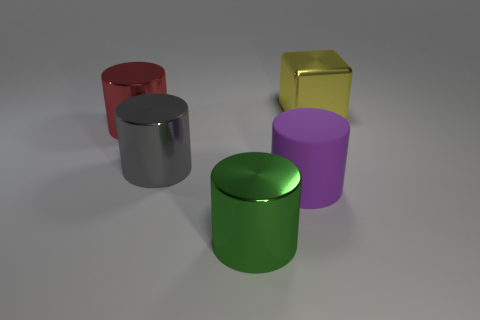Subtract all large purple rubber cylinders. How many cylinders are left? 3 Add 5 large gray things. How many objects exist? 10 Subtract all gray cylinders. How many cylinders are left? 3 Subtract all purple cylinders. Subtract all blue blocks. How many cylinders are left? 3 Subtract all cubes. How many objects are left? 4 Add 1 cyan shiny cylinders. How many cyan shiny cylinders exist? 1 Subtract 1 yellow blocks. How many objects are left? 4 Subtract all red shiny cylinders. Subtract all small brown metallic spheres. How many objects are left? 4 Add 4 large yellow blocks. How many large yellow blocks are left? 5 